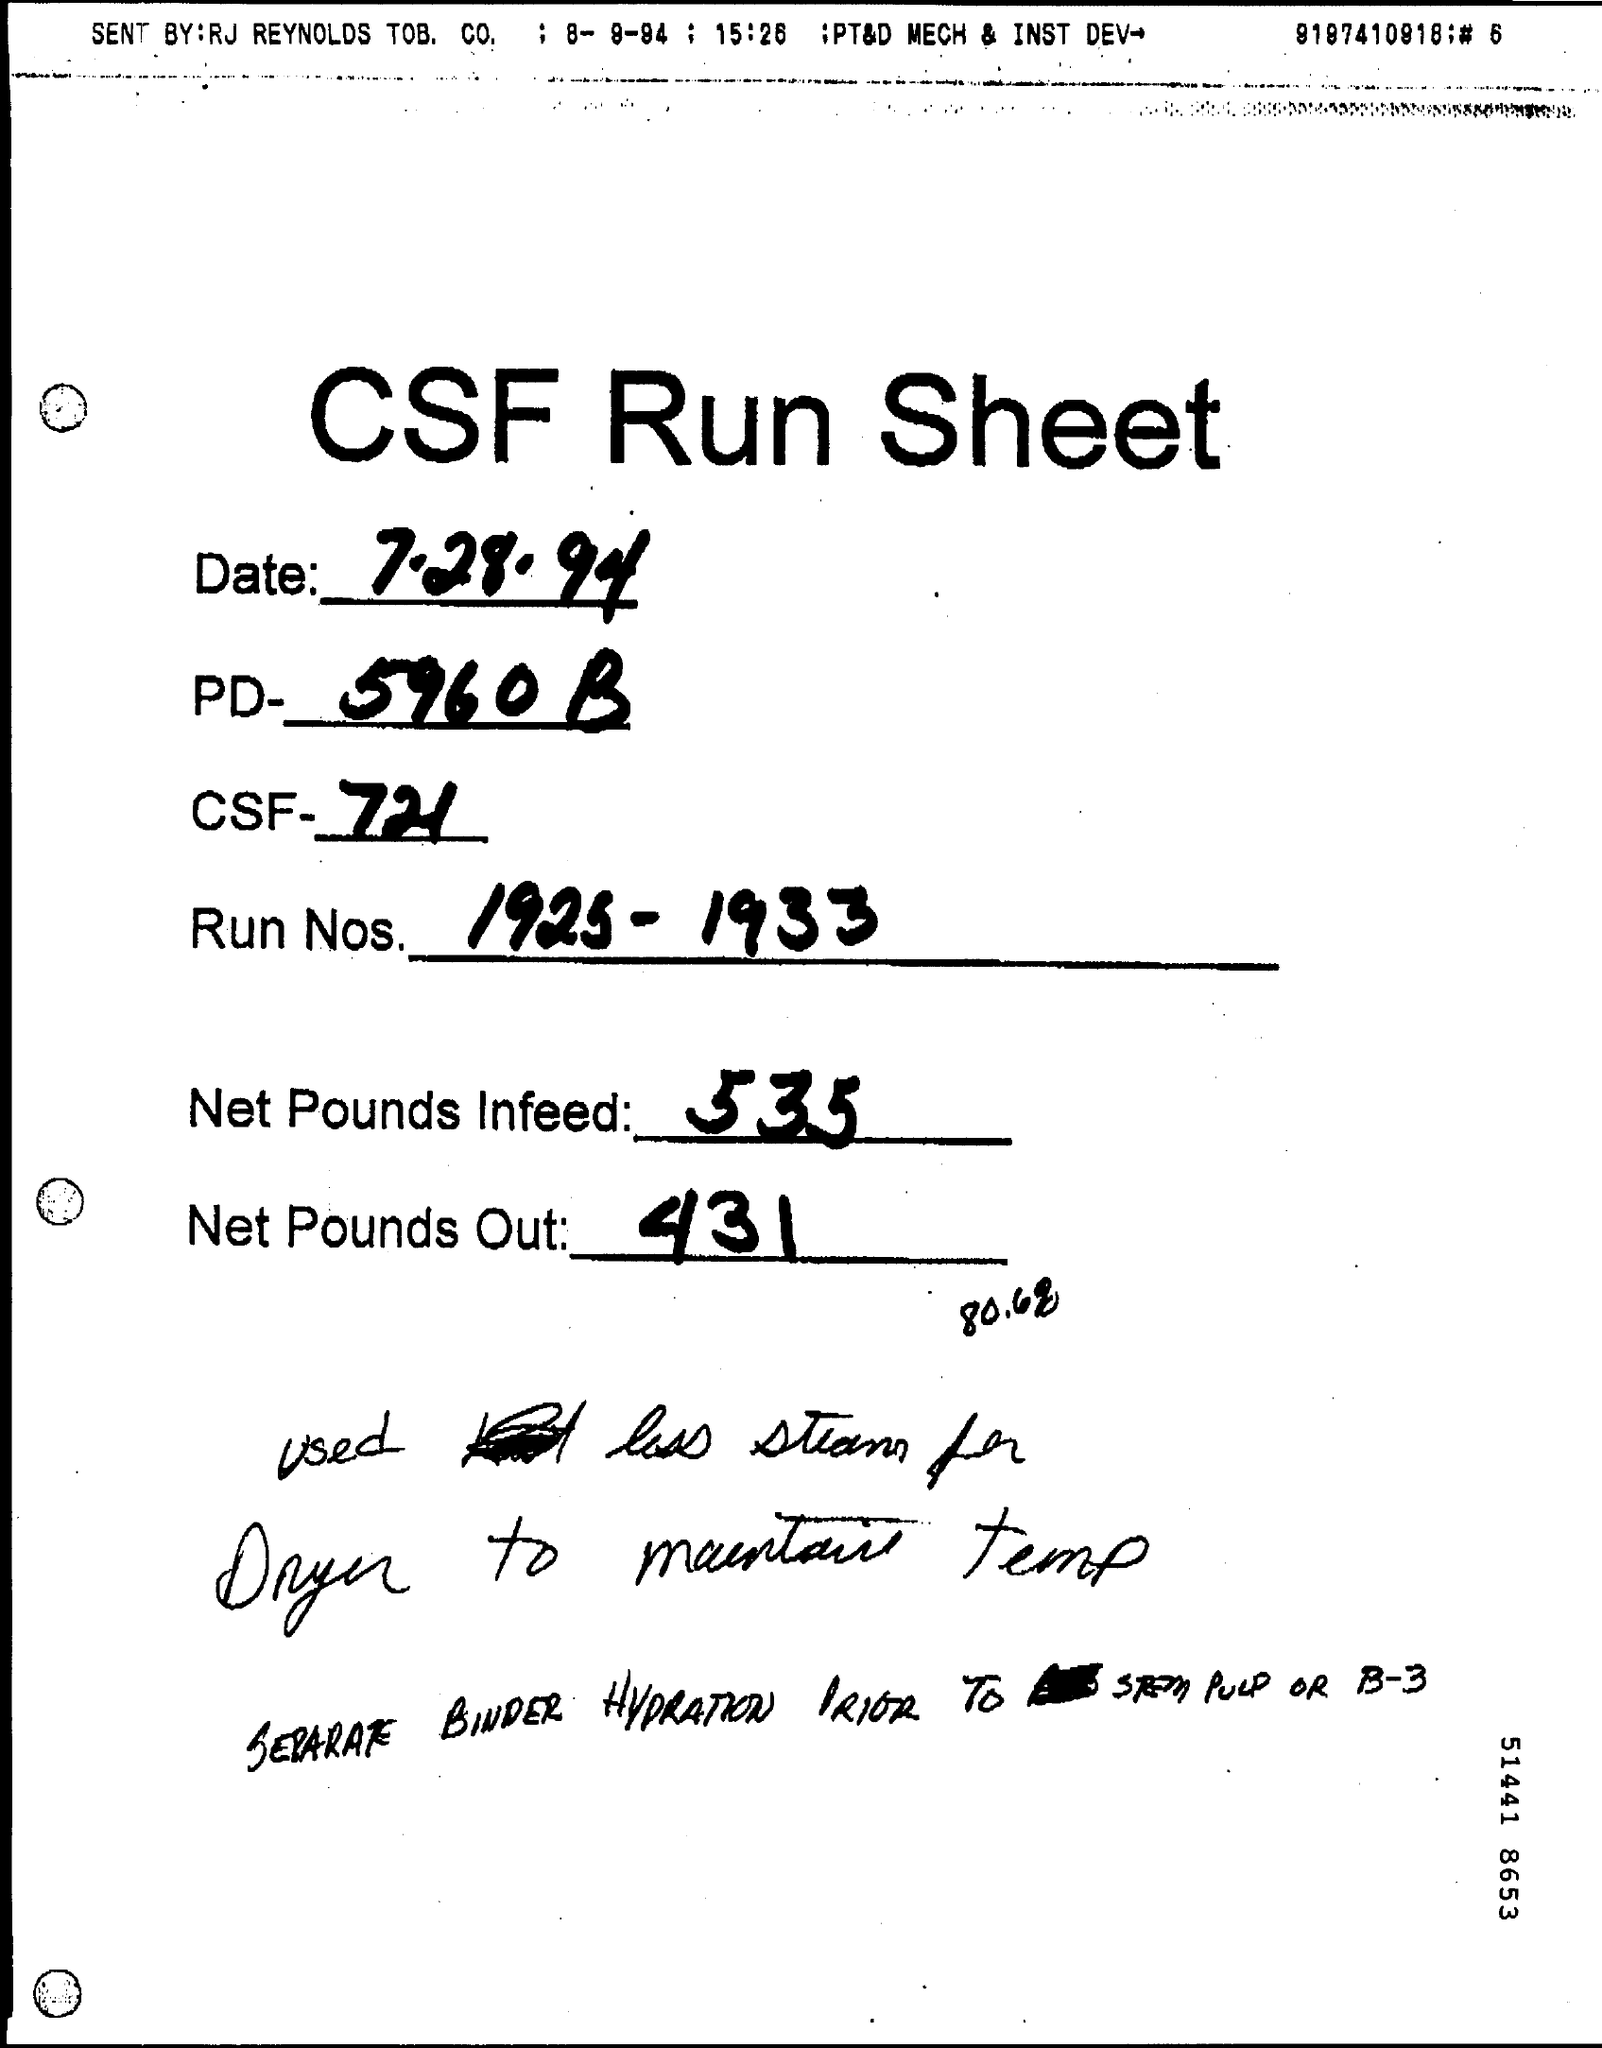What is the date mentioned in this Sheet ?
Offer a terse response. 7.28.94. What is written in the PD Field ?
Your response must be concise. 5960 B. What is written in the Net Pounds Infeed Field ?
Offer a very short reply. 535. What is written in the Net Pounds Out Field?
Make the answer very short. 431. 